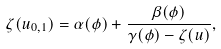Convert formula to latex. <formula><loc_0><loc_0><loc_500><loc_500>\zeta ( u _ { 0 , 1 } ) = \alpha ( \phi ) + \frac { \beta ( \phi ) } { \gamma ( \phi ) - \zeta ( u ) } ,</formula> 